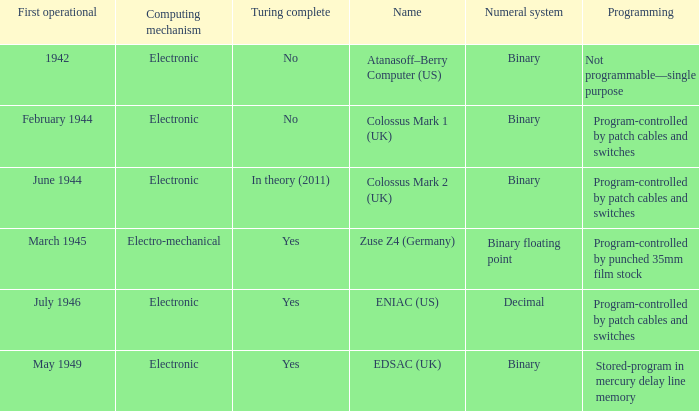What's the name with first operational being march 1945 Zuse Z4 (Germany). 